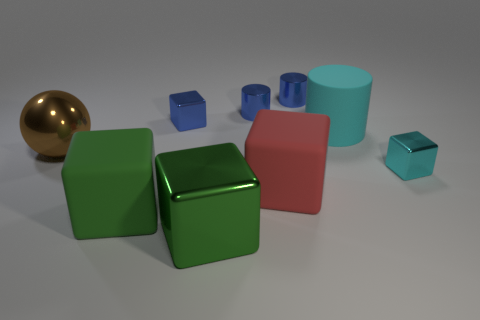Subtract all blue cubes. How many cubes are left? 4 Subtract all red cubes. How many cubes are left? 4 Subtract all brown cubes. Subtract all cyan spheres. How many cubes are left? 5 Add 1 blue objects. How many objects exist? 10 Subtract all cylinders. How many objects are left? 6 Subtract 0 yellow cubes. How many objects are left? 9 Subtract all small cubes. Subtract all shiny objects. How many objects are left? 1 Add 5 big things. How many big things are left? 10 Add 3 blue cubes. How many blue cubes exist? 4 